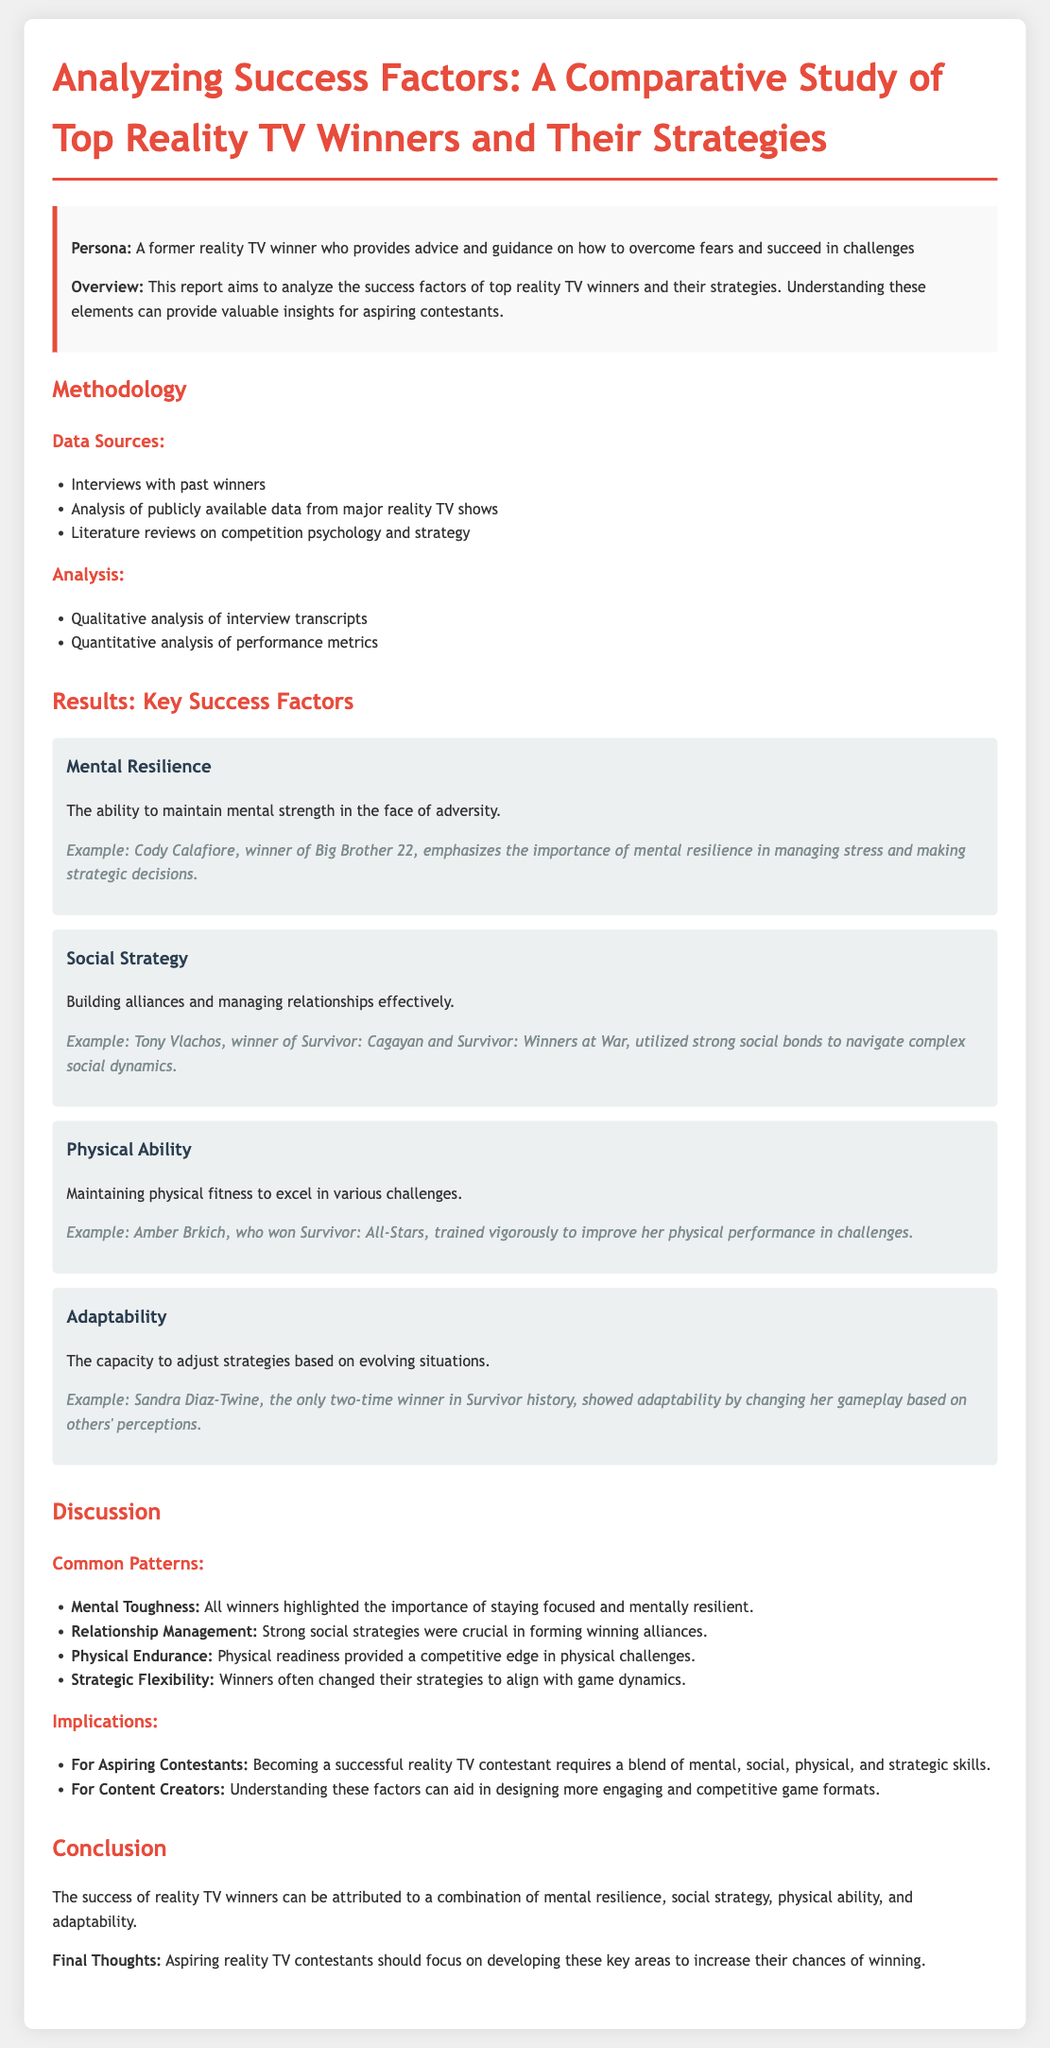What are the key success factors identified in the report? The report lists success factors including Mental Resilience, Social Strategy, Physical Ability, and Adaptability.
Answer: Mental Resilience, Social Strategy, Physical Ability, Adaptability Who is the winner emphasized for their mental resilience? Cody Calafiore, the winner of Big Brother 22, is highlighted for his mental resilience in the report.
Answer: Cody Calafiore What is one common pattern observed among all winners? The document notes that all winners emphasized the importance of mental toughness.
Answer: Mental Toughness How many times has Sandra Diaz-Twine won Survivor? The report states she is the only two-time winner in Survivor history.
Answer: Two times What is recommended for aspiring reality TV contestants? The report suggests that they should focus on developing several key skills for success.
Answer: Key skills What type of analysis was performed on interview transcripts? Qualitative analysis was conducted on the interview transcripts as per the methodology section.
Answer: Qualitative analysis Which winner is mentioned for their strong social strategy? The report names Tony Vlachos, the winner of Survivor: Cagayan and Survivor: Winners at War, for his social strategy.
Answer: Tony Vlachos What is the design purpose mentioned for content creators in the discussion section? Understanding success factors can aid content creators in designing more engaging and competitive game formats.
Answer: Engaging and competitive game formats 